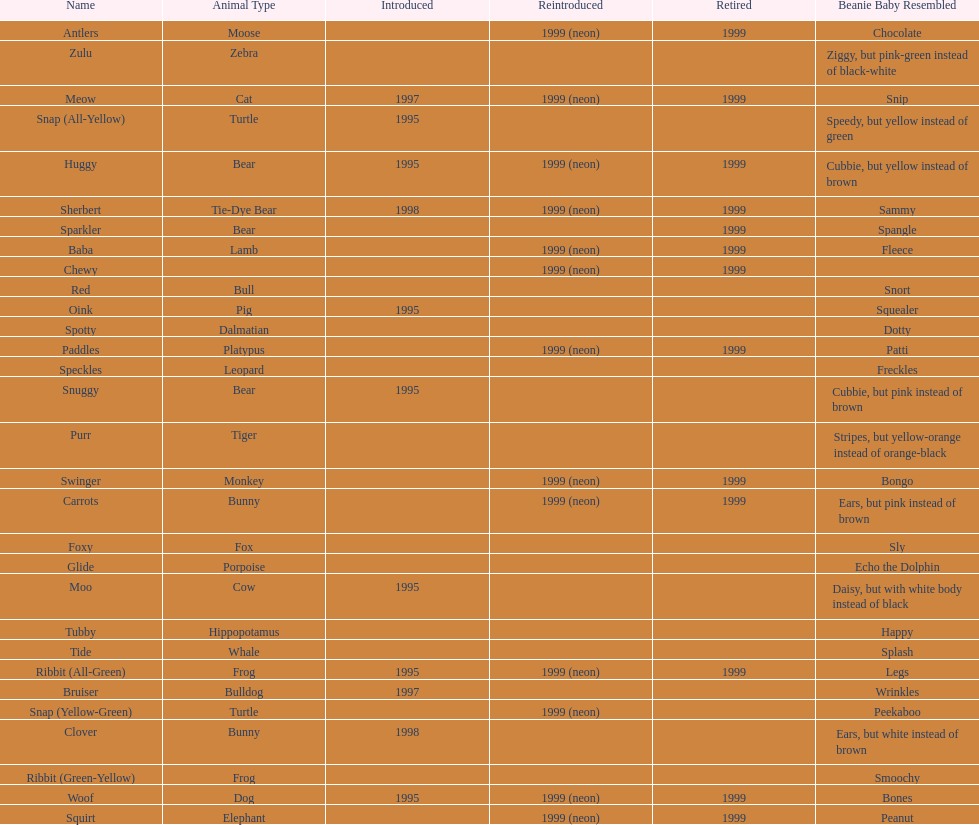What is the number of frog pillow pals? 2. 